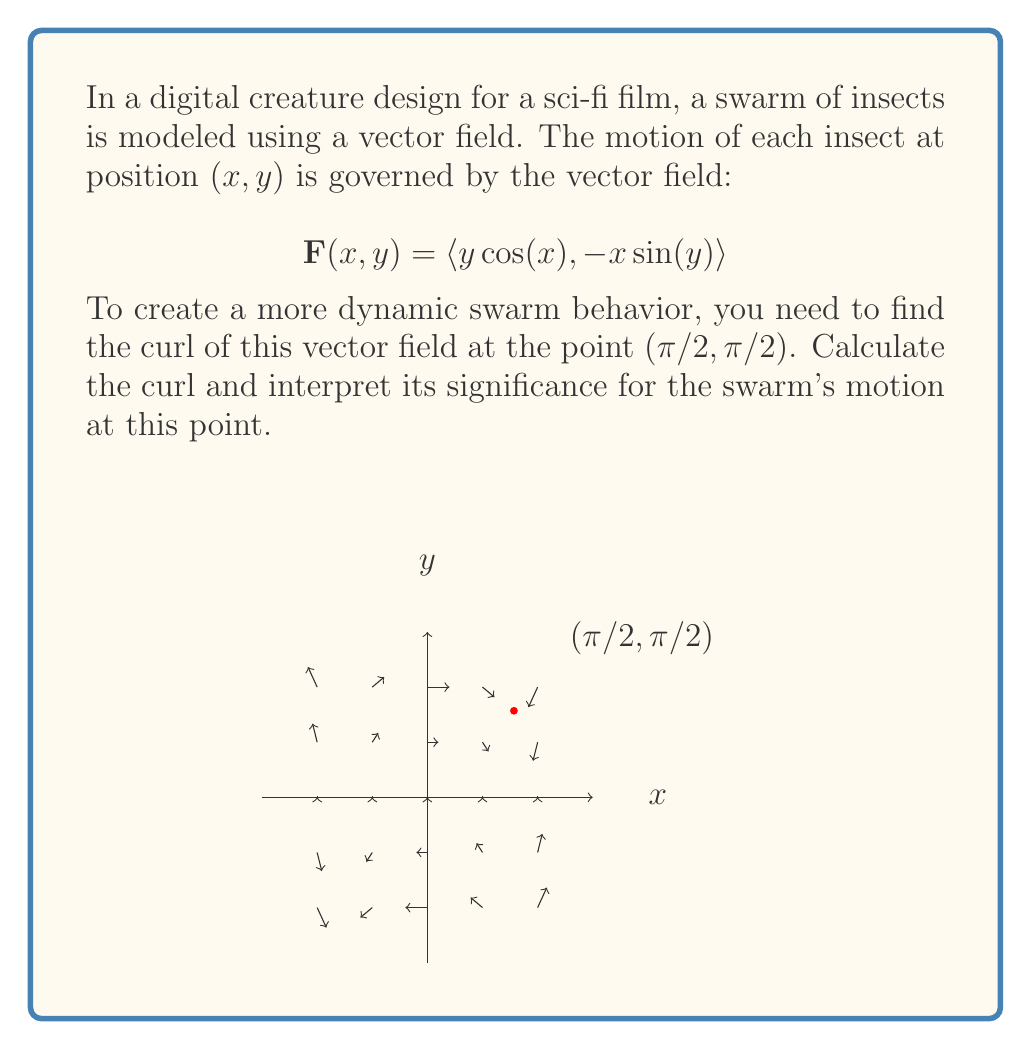What is the answer to this math problem? To solve this problem, we'll follow these steps:

1) The curl of a 2D vector field $\mathbf{F}(x,y) = \langle P(x,y), Q(x,y) \rangle$ is given by:

   $$\text{curl }\mathbf{F} = \frac{\partial Q}{\partial x} - \frac{\partial P}{\partial y}$$

2) In our case, $P(x,y) = y\cos(x)$ and $Q(x,y) = -x\sin(y)$.

3) Let's calculate the partial derivatives:

   $\frac{\partial Q}{\partial x} = -\sin(y)$
   
   $\frac{\partial P}{\partial y} = \cos(x)$

4) Now we can form the curl:

   $$\text{curl }\mathbf{F} = -\sin(y) - \cos(x)$$

5) We need to evaluate this at the point $(π/2, π/2)$:

   $$\text{curl }\mathbf{F}(π/2, π/2) = -\sin(π/2) - \cos(π/2) = -1 - 0 = -1$$

6) Interpretation: The negative curl at this point indicates that the insects are rotating clockwise around this point. The magnitude of 1 suggests a moderate strength of rotation.

For the film's creature design, this means that at the point $(π/2, π/2)$, the swarm will exhibit a clockwise circular motion, adding an interesting dynamic to the overall swarm behavior.
Answer: $-1$ 